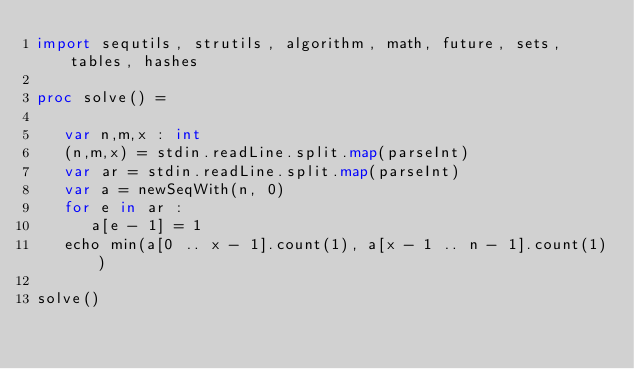<code> <loc_0><loc_0><loc_500><loc_500><_Nim_>import sequtils, strutils, algorithm, math, future, sets, tables, hashes

proc solve() =
   
   var n,m,x : int
   (n,m,x) = stdin.readLine.split.map(parseInt)
   var ar = stdin.readLine.split.map(parseInt)
   var a = newSeqWith(n, 0)
   for e in ar : 
      a[e - 1] = 1
   echo min(a[0 .. x - 1].count(1), a[x - 1 .. n - 1].count(1))

solve()</code> 